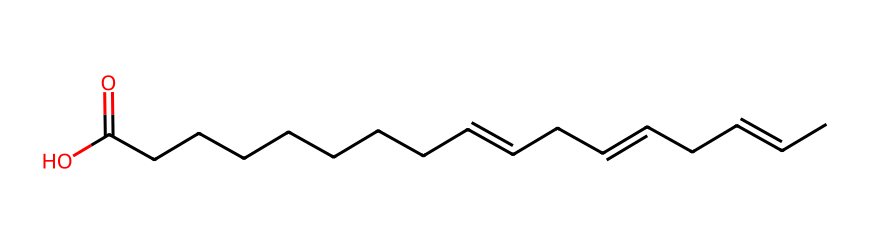What is the molecular formula of this compound? By analyzing the SMILES representation, we can identify the number of carbon (C), hydrogen (H), and oxygen (O) atoms. The given structure shows 18 carbons, 34 hydrogens, and 2 oxygens, leading us to derive the molecular formula C18H34O2.
Answer: C18H34O2 How many double bonds are present? Observing the SMILES, we notice that the '=' sign indicates double bonds between certain carbon atoms. Upon tallying these, we find there are three double bonds in the structure.
Answer: 3 What is the functional group present in this molecule? The presence of the "C(=O)O" section indicates the molecule has a carboxylic acid functional group, characterized by a carbonyl bonded to a hydroxyl group (–COOH).
Answer: carboxylic acid Is this molecule saturated or unsaturated? The presence of double bonds suggests that the molecule cannot be fully saturated with hydrogen atoms. A saturated molecule would not contain any double bonds. Thus, this molecule is classified as unsaturated.
Answer: unsaturated What type of fatty acid is represented by this structure? Given the structure has multiple double bonds and is derived from the fatty acid chain, it is categorized as a polyunsaturated fatty acid (PUFA), emphasizing the presence of two or more double bonds.
Answer: polyunsaturated fatty acid What is the total number of carbon atoms in the longest chain? By counting the continuous carbon atoms in the SMILES string, we identify that the longest chain contains a total of 18 carbon atoms, which forms the backbone of the fatty acid.
Answer: 18 